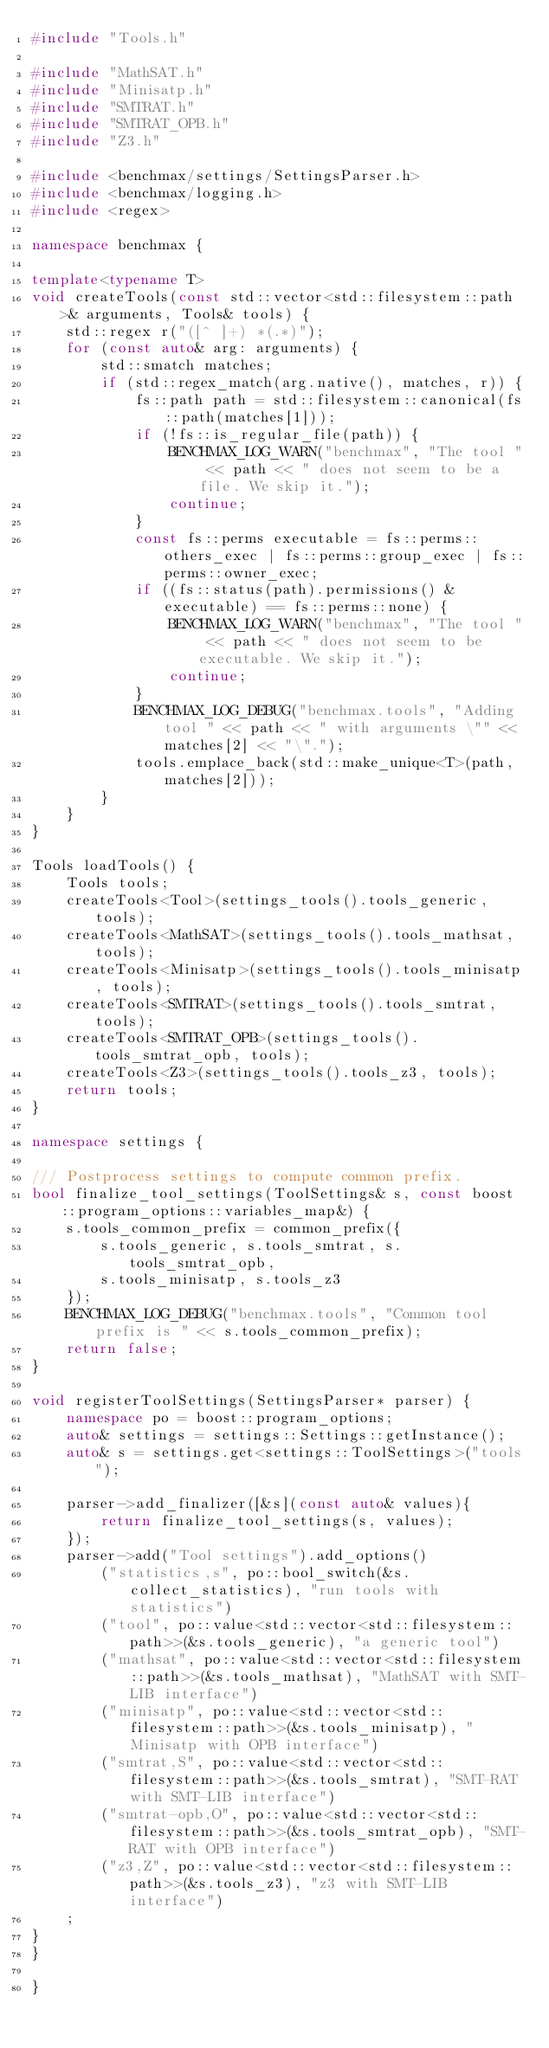<code> <loc_0><loc_0><loc_500><loc_500><_C++_>#include "Tools.h"

#include "MathSAT.h"
#include "Minisatp.h"
#include "SMTRAT.h"
#include "SMTRAT_OPB.h"
#include "Z3.h"

#include <benchmax/settings/SettingsParser.h>
#include <benchmax/logging.h>
#include <regex>

namespace benchmax {

template<typename T>
void createTools(const std::vector<std::filesystem::path>& arguments, Tools& tools) {
	std::regex r("([^ ]+) *(.*)");
	for (const auto& arg: arguments) {
		std::smatch matches;
		if (std::regex_match(arg.native(), matches, r)) {
			fs::path path = std::filesystem::canonical(fs::path(matches[1]));
			if (!fs::is_regular_file(path)) {
				BENCHMAX_LOG_WARN("benchmax", "The tool " << path << " does not seem to be a file. We skip it.");
				continue;
			}
			const fs::perms executable = fs::perms::others_exec | fs::perms::group_exec | fs::perms::owner_exec;
			if ((fs::status(path).permissions() & executable) == fs::perms::none) {
				BENCHMAX_LOG_WARN("benchmax", "The tool " << path << " does not seem to be executable. We skip it.");
				continue;
			}
			BENCHMAX_LOG_DEBUG("benchmax.tools", "Adding tool " << path << " with arguments \"" << matches[2] << "\".");
			tools.emplace_back(std::make_unique<T>(path, matches[2]));
		}
	}
}

Tools loadTools() {
	Tools tools;
	createTools<Tool>(settings_tools().tools_generic, tools);
	createTools<MathSAT>(settings_tools().tools_mathsat, tools);
	createTools<Minisatp>(settings_tools().tools_minisatp, tools);
	createTools<SMTRAT>(settings_tools().tools_smtrat, tools);
	createTools<SMTRAT_OPB>(settings_tools().tools_smtrat_opb, tools);
	createTools<Z3>(settings_tools().tools_z3, tools);
	return tools;
}

namespace settings {

/// Postprocess settings to compute common prefix.
bool finalize_tool_settings(ToolSettings& s, const boost::program_options::variables_map&) {
	s.tools_common_prefix = common_prefix({
		s.tools_generic, s.tools_smtrat, s.tools_smtrat_opb,
		s.tools_minisatp, s.tools_z3
	});
	BENCHMAX_LOG_DEBUG("benchmax.tools", "Common tool prefix is " << s.tools_common_prefix);
	return false;
}

void registerToolSettings(SettingsParser* parser) {
	namespace po = boost::program_options;
	auto& settings = settings::Settings::getInstance();
	auto& s = settings.get<settings::ToolSettings>("tools");

	parser->add_finalizer([&s](const auto& values){
		return finalize_tool_settings(s, values);
	});
	parser->add("Tool settings").add_options()
		("statistics,s", po::bool_switch(&s.collect_statistics), "run tools with statistics")
		("tool", po::value<std::vector<std::filesystem::path>>(&s.tools_generic), "a generic tool")
		("mathsat", po::value<std::vector<std::filesystem::path>>(&s.tools_mathsat), "MathSAT with SMT-LIB interface")
		("minisatp", po::value<std::vector<std::filesystem::path>>(&s.tools_minisatp), "Minisatp with OPB interface")
		("smtrat,S", po::value<std::vector<std::filesystem::path>>(&s.tools_smtrat), "SMT-RAT with SMT-LIB interface")
		("smtrat-opb,O", po::value<std::vector<std::filesystem::path>>(&s.tools_smtrat_opb), "SMT-RAT with OPB interface")
		("z3,Z", po::value<std::vector<std::filesystem::path>>(&s.tools_z3), "z3 with SMT-LIB interface")
	;
}
}

}</code> 